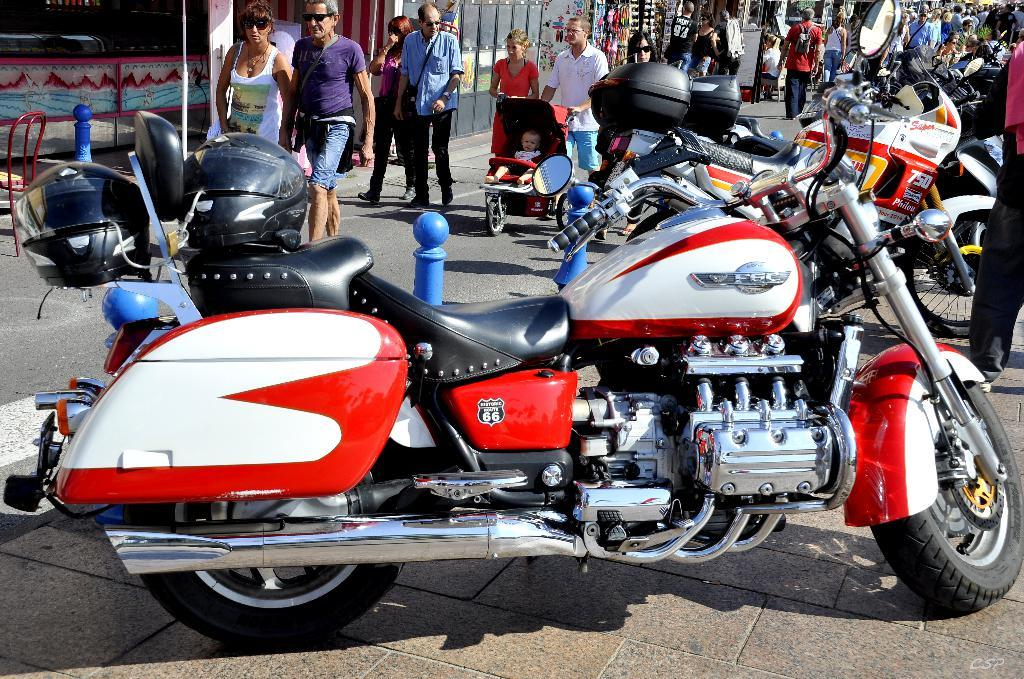<image>
Render a clear and concise summary of the photo. A motorcycle which has the numbers 66 visible on it. 